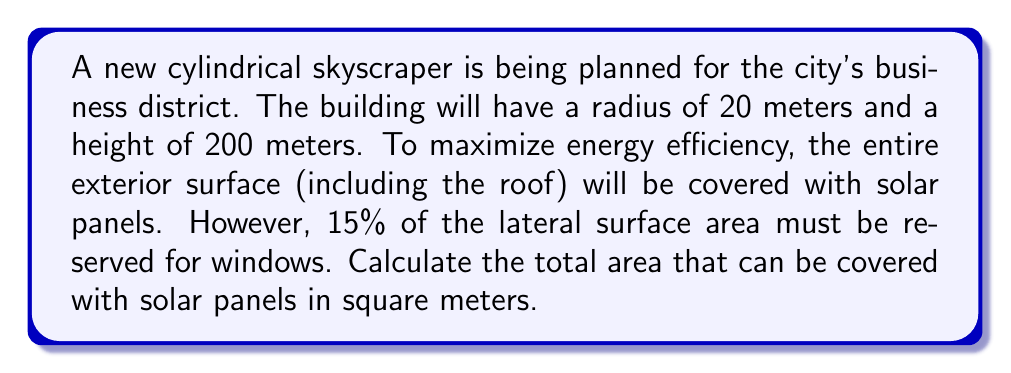Teach me how to tackle this problem. Let's approach this step-by-step:

1) First, we need to calculate the total surface area of the cylindrical building.

   The surface area of a cylinder is given by the formula:
   $$A = 2\pi r^2 + 2\pi rh$$
   where $r$ is the radius and $h$ is the height.

2) Let's substitute our values:
   $$A = 2\pi (20)^2 + 2\pi (20)(200)$$

3) Simplify:
   $$A = 2\pi (400) + 2\pi (4000)$$
   $$A = 800\pi + 8000\pi$$
   $$A = 8800\pi$$

4) Now, we need to calculate the lateral surface area (the area of the curved side):
   $$A_{lateral} = 2\pi rh = 2\pi (20)(200) = 8000\pi$$

5) 15% of this area must be reserved for windows:
   $$A_{windows} = 0.15 * 8000\pi = 1200\pi$$

6) Therefore, the area available for solar panels is:
   $$A_{solar} = A_{total} - A_{windows}$$
   $$A_{solar} = 8800\pi - 1200\pi = 7600\pi$$

7) Convert to square meters:
   $$A_{solar} = 7600\pi \approx 23,876.10 \text{ m}^2$$
Answer: $23,876.10 \text{ m}^2$ 